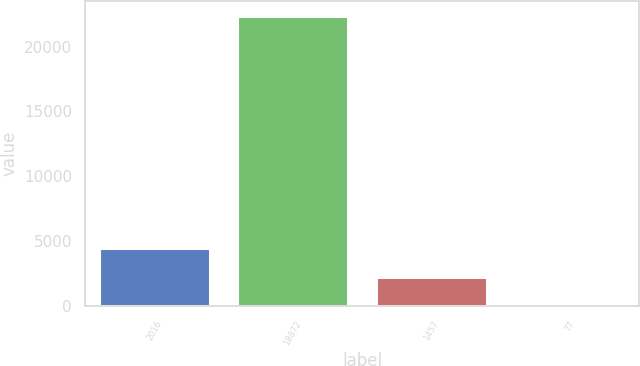<chart> <loc_0><loc_0><loc_500><loc_500><bar_chart><fcel>2016<fcel>18872<fcel>1457<fcel>77<nl><fcel>4482.56<fcel>22398<fcel>2243.13<fcel>3.7<nl></chart> 